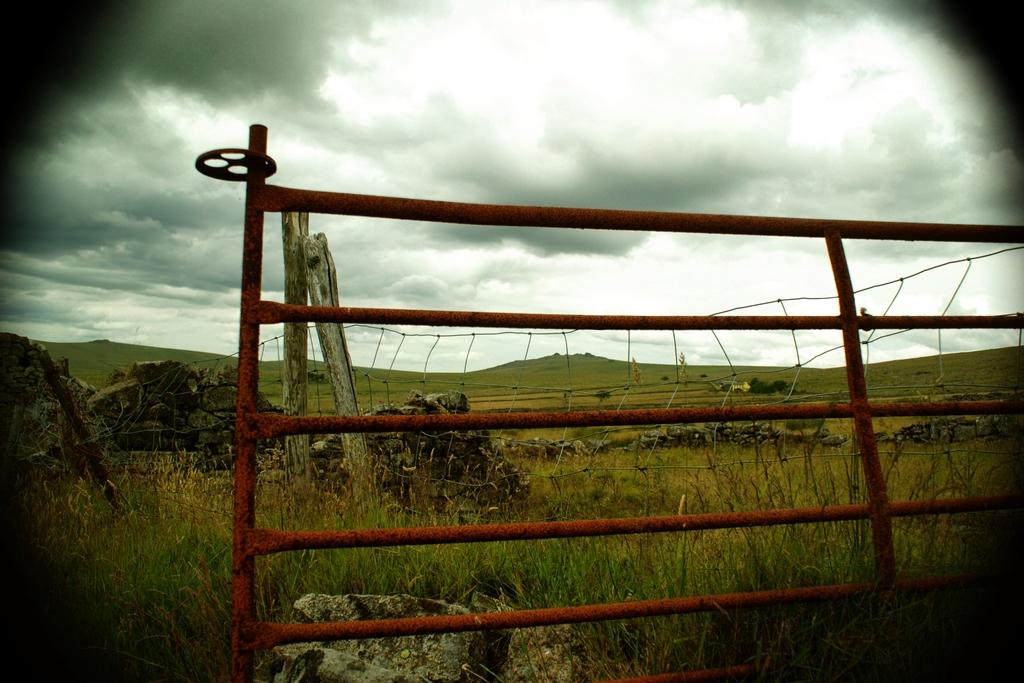What type of structure can be seen in the image? There are iron grilles in the image. What material are the poles behind the grilles made of? The wooden poles behind the grilles are made of wood. What type of barrier is present in the image? There is a fence in the image. What type of landscape can be seen in the image? Hills are visible in the image. What type of vegetation is present in the image? Grass is present in the image. What is the condition of the sky in the image? The sky is cloudy in the image. What type of doctor can be seen treating a patient in the image? There is no doctor or patient present in the image; it features iron grilles, wooden poles, a fence, hills, grass, and a cloudy sky. Is there a river flowing through the hills in the image? There is no river visible in the image; it only shows hills, grass, and a cloudy sky. 